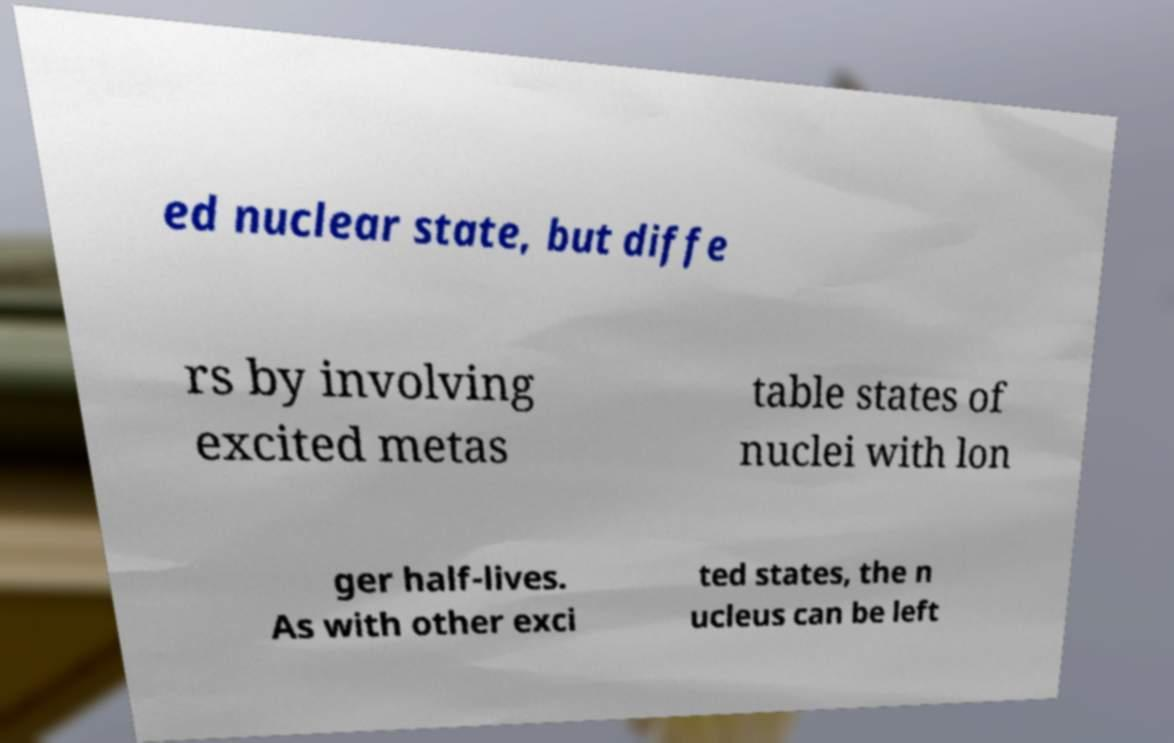Please identify and transcribe the text found in this image. ed nuclear state, but diffe rs by involving excited metas table states of nuclei with lon ger half-lives. As with other exci ted states, the n ucleus can be left 